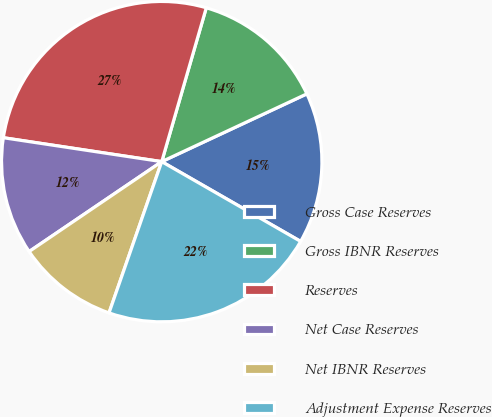Convert chart to OTSL. <chart><loc_0><loc_0><loc_500><loc_500><pie_chart><fcel>Gross Case Reserves<fcel>Gross IBNR Reserves<fcel>Reserves<fcel>Net Case Reserves<fcel>Net IBNR Reserves<fcel>Adjustment Expense Reserves<nl><fcel>15.25%<fcel>13.56%<fcel>27.1%<fcel>11.87%<fcel>10.18%<fcel>22.04%<nl></chart> 